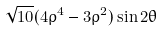Convert formula to latex. <formula><loc_0><loc_0><loc_500><loc_500>\sqrt { 1 0 } ( 4 \rho ^ { 4 } - 3 \rho ^ { 2 } ) \sin 2 \theta</formula> 